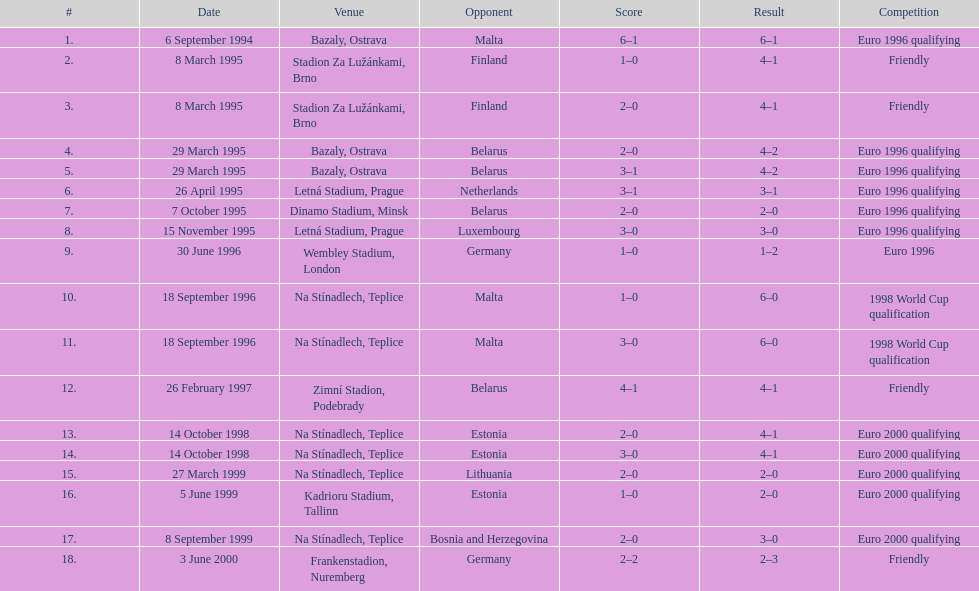Can you give me this table as a dict? {'header': ['#', 'Date', 'Venue', 'Opponent', 'Score', 'Result', 'Competition'], 'rows': [['1.', '6 September 1994', 'Bazaly, Ostrava', 'Malta', '6–1', '6–1', 'Euro 1996 qualifying'], ['2.', '8 March 1995', 'Stadion Za Lužánkami, Brno', 'Finland', '1–0', '4–1', 'Friendly'], ['3.', '8 March 1995', 'Stadion Za Lužánkami, Brno', 'Finland', '2–0', '4–1', 'Friendly'], ['4.', '29 March 1995', 'Bazaly, Ostrava', 'Belarus', '2–0', '4–2', 'Euro 1996 qualifying'], ['5.', '29 March 1995', 'Bazaly, Ostrava', 'Belarus', '3–1', '4–2', 'Euro 1996 qualifying'], ['6.', '26 April 1995', 'Letná Stadium, Prague', 'Netherlands', '3–1', '3–1', 'Euro 1996 qualifying'], ['7.', '7 October 1995', 'Dinamo Stadium, Minsk', 'Belarus', '2–0', '2–0', 'Euro 1996 qualifying'], ['8.', '15 November 1995', 'Letná Stadium, Prague', 'Luxembourg', '3–0', '3–0', 'Euro 1996 qualifying'], ['9.', '30 June 1996', 'Wembley Stadium, London', 'Germany', '1–0', '1–2', 'Euro 1996'], ['10.', '18 September 1996', 'Na Stínadlech, Teplice', 'Malta', '1–0', '6–0', '1998 World Cup qualification'], ['11.', '18 September 1996', 'Na Stínadlech, Teplice', 'Malta', '3–0', '6–0', '1998 World Cup qualification'], ['12.', '26 February 1997', 'Zimní Stadion, Podebrady', 'Belarus', '4–1', '4–1', 'Friendly'], ['13.', '14 October 1998', 'Na Stínadlech, Teplice', 'Estonia', '2–0', '4–1', 'Euro 2000 qualifying'], ['14.', '14 October 1998', 'Na Stínadlech, Teplice', 'Estonia', '3–0', '4–1', 'Euro 2000 qualifying'], ['15.', '27 March 1999', 'Na Stínadlech, Teplice', 'Lithuania', '2–0', '2–0', 'Euro 2000 qualifying'], ['16.', '5 June 1999', 'Kadrioru Stadium, Tallinn', 'Estonia', '1–0', '2–0', 'Euro 2000 qualifying'], ['17.', '8 September 1999', 'Na Stínadlech, Teplice', 'Bosnia and Herzegovina', '2–0', '3–0', 'Euro 2000 qualifying'], ['18.', '3 June 2000', 'Frankenstadion, Nuremberg', 'Germany', '2–2', '2–3', 'Friendly']]} Which team did czech republic score the most goals against? Malta. 